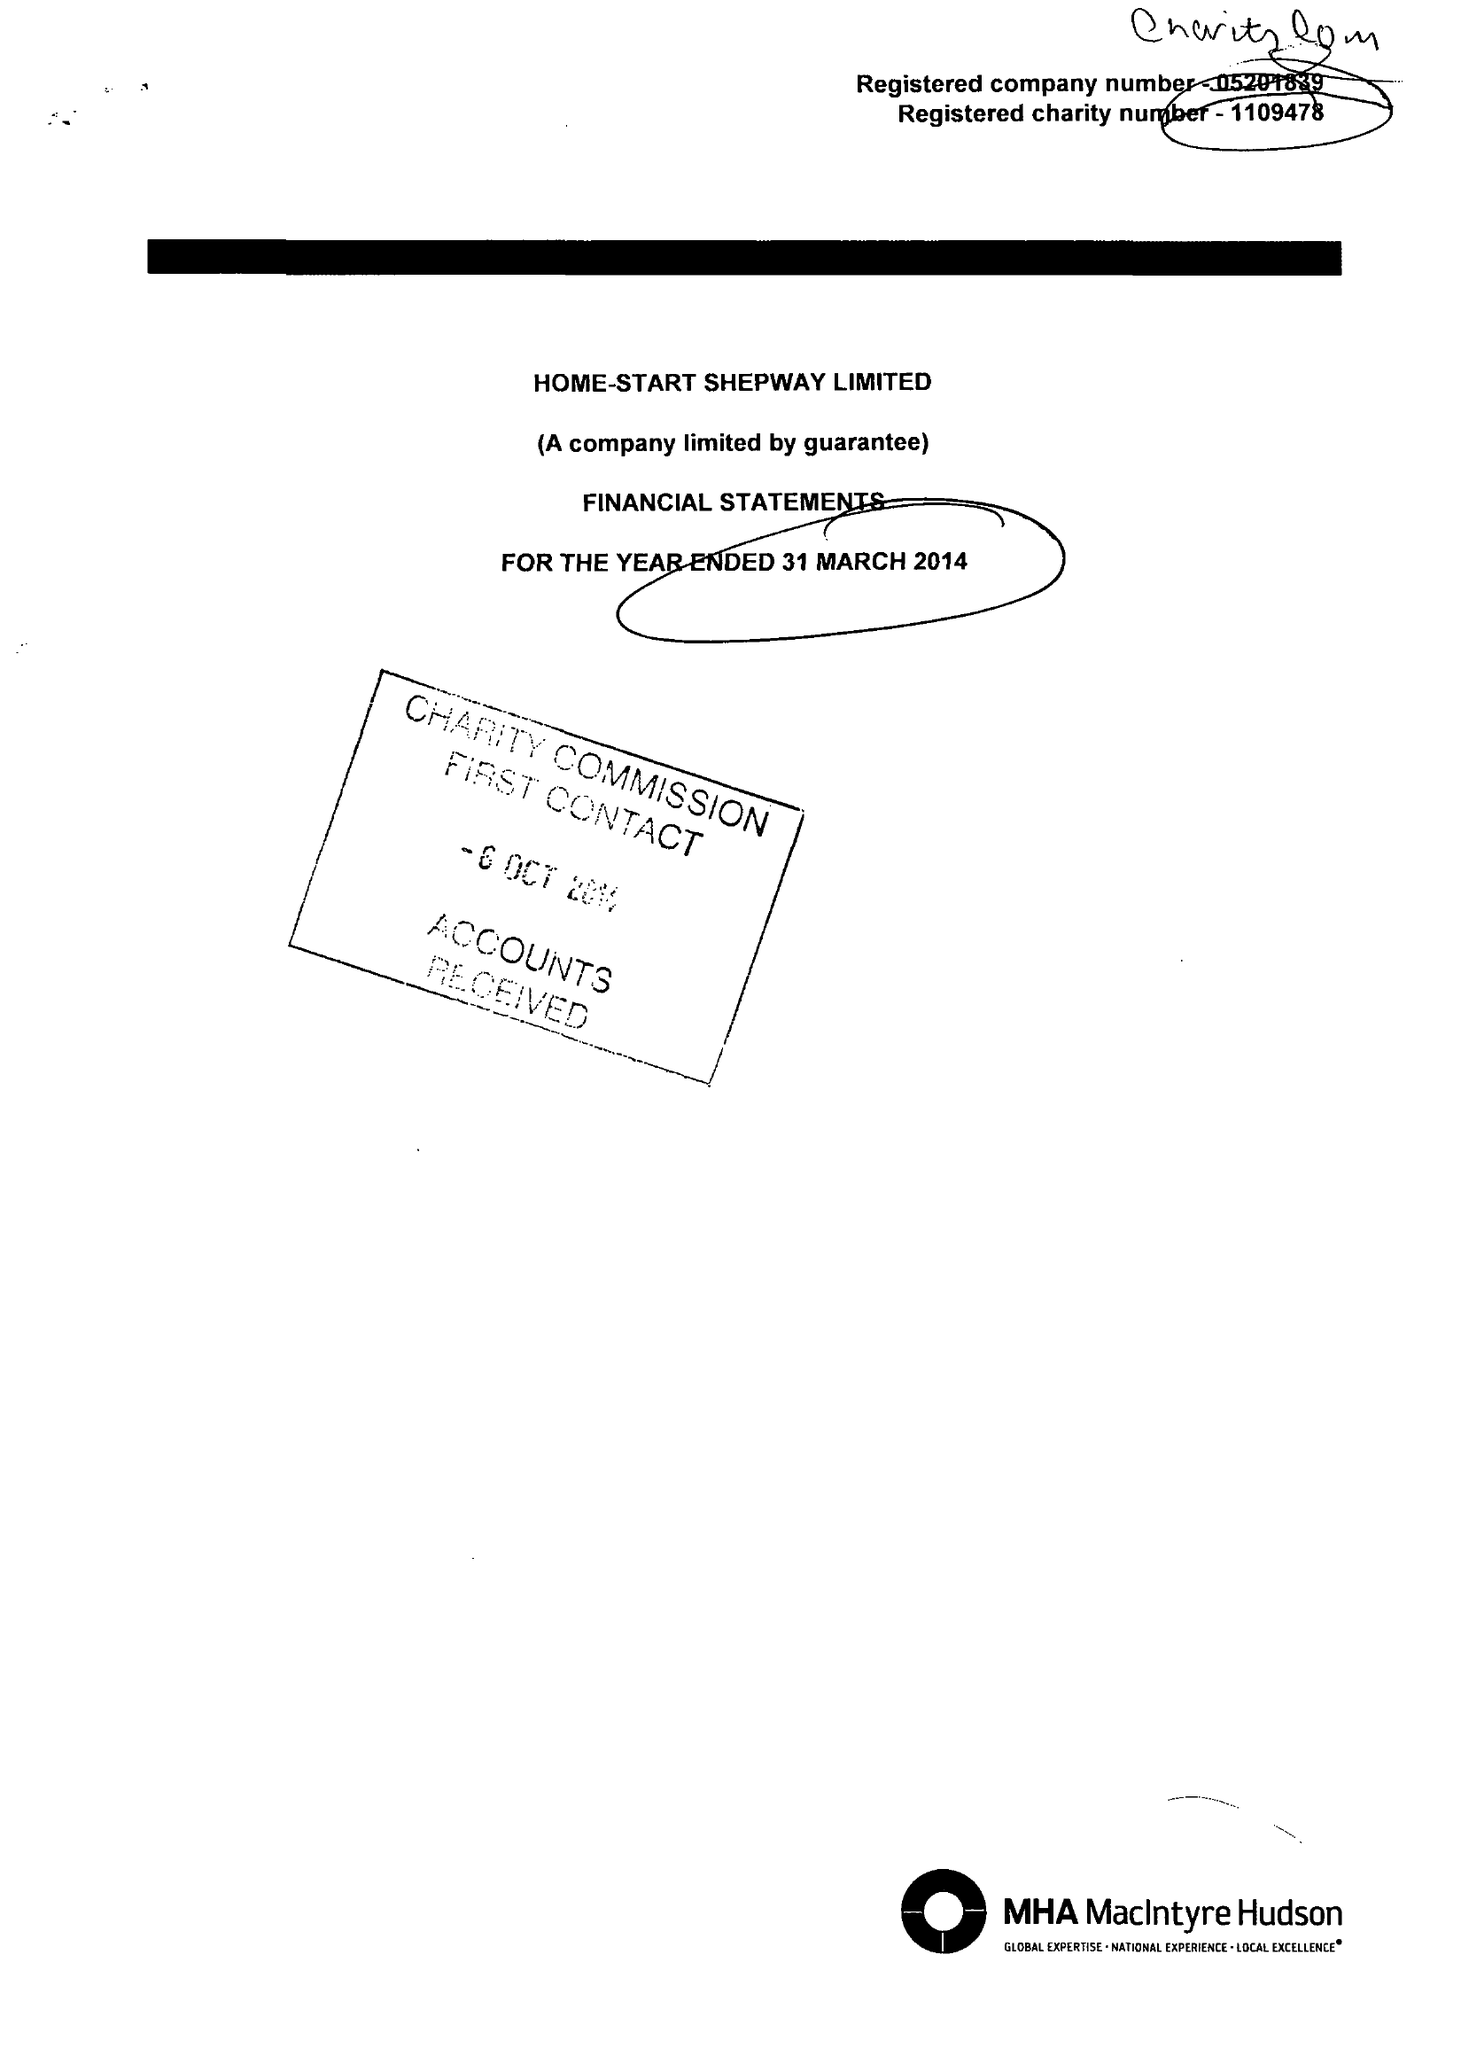What is the value for the address__street_line?
Answer the question using a single word or phrase. 24 CHERITON GARDENS 